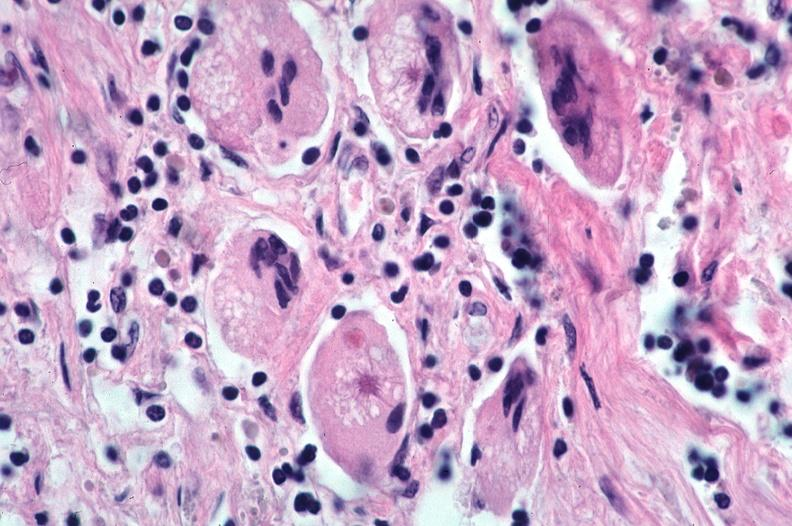what is present?
Answer the question using a single word or phrase. Respiratory 